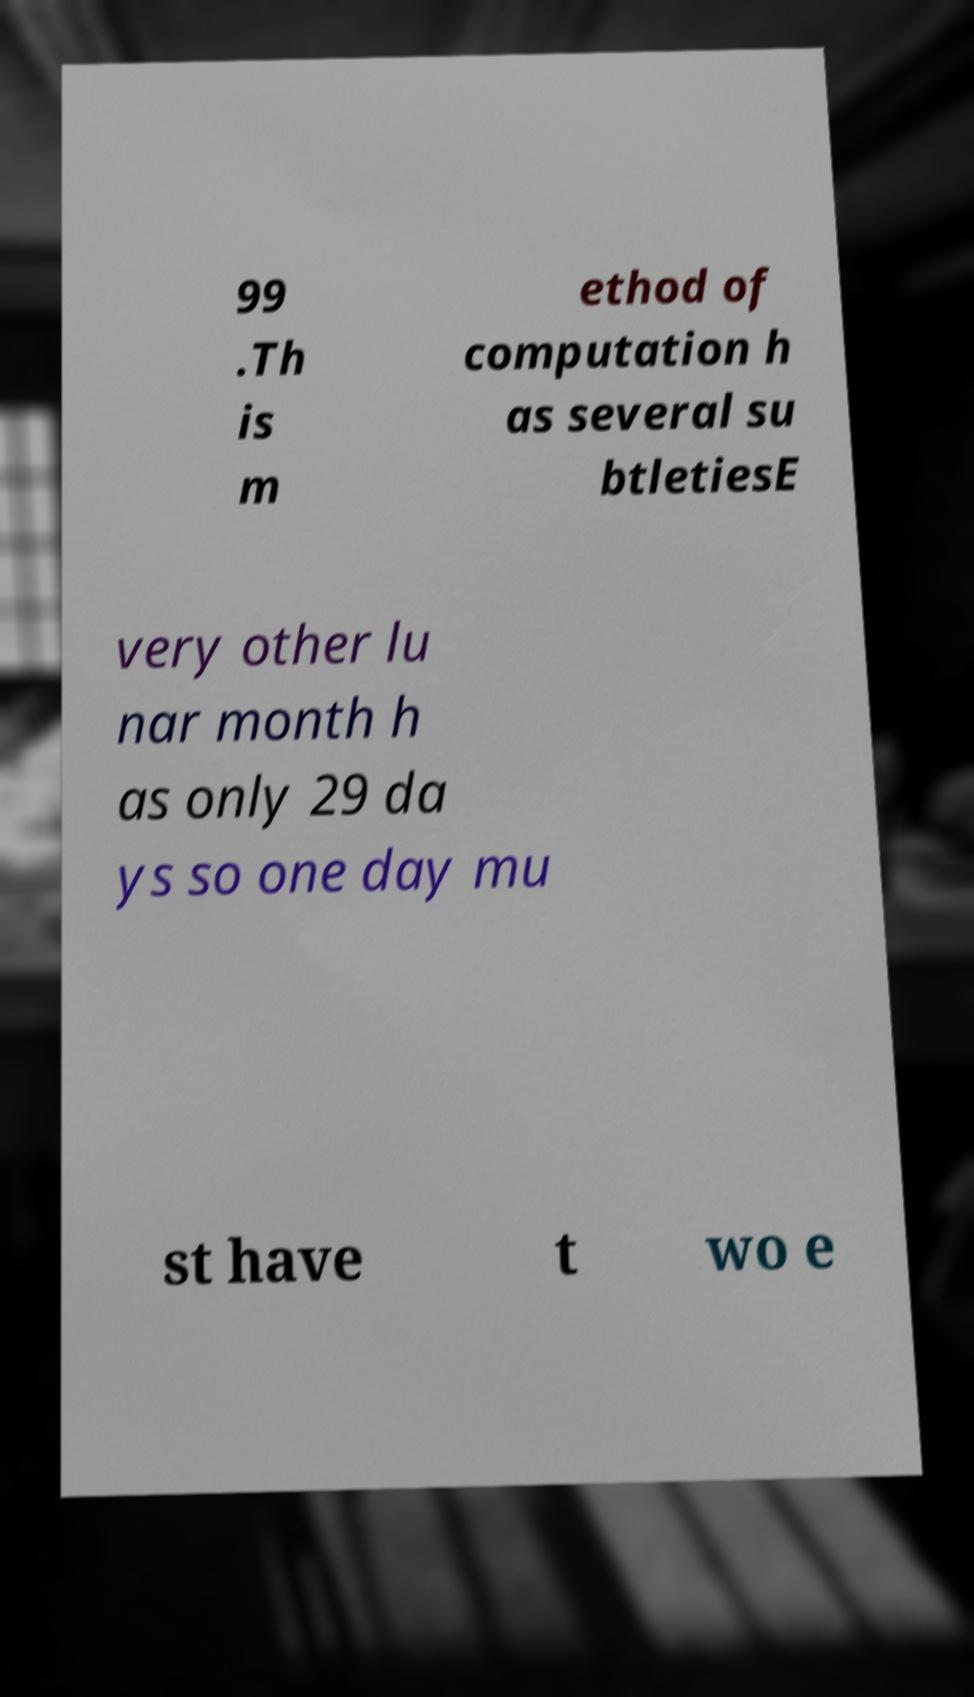I need the written content from this picture converted into text. Can you do that? 99 .Th is m ethod of computation h as several su btletiesE very other lu nar month h as only 29 da ys so one day mu st have t wo e 